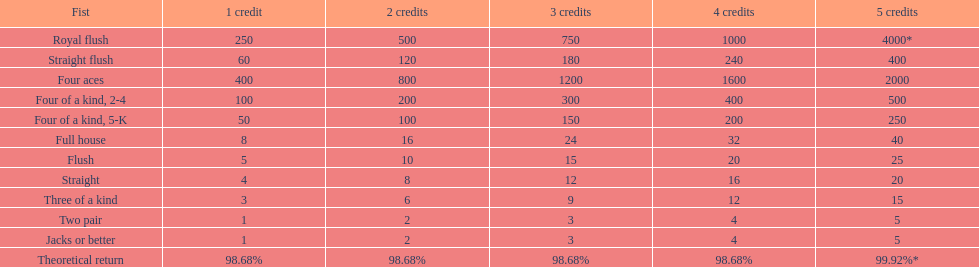Which has a superior rank: a straight or a flush? Flush. 